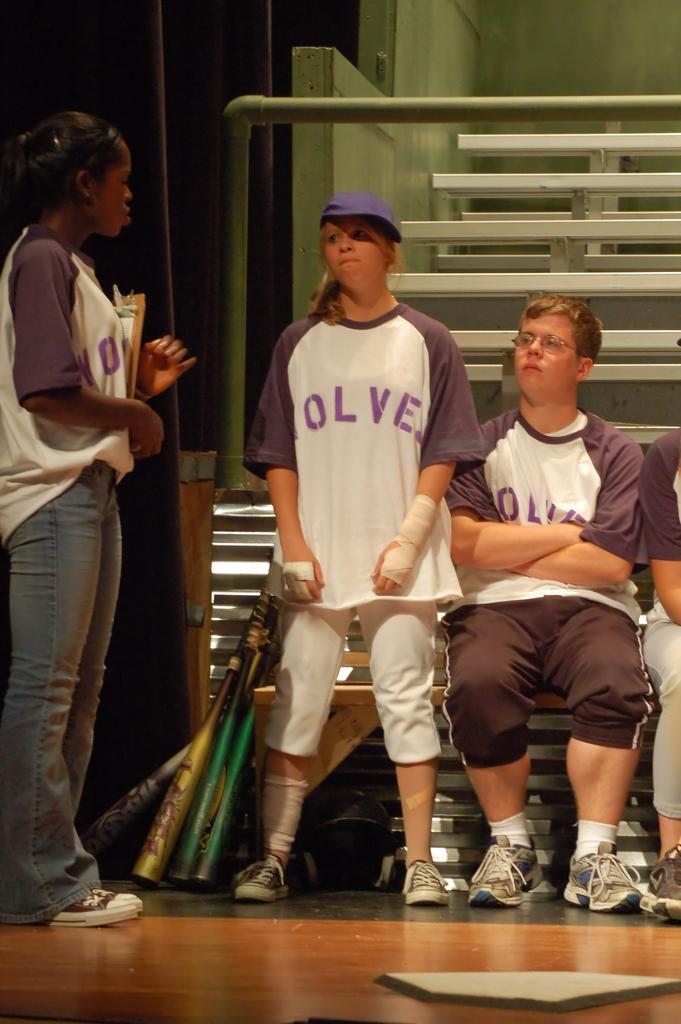<image>
Render a clear and concise summary of the photo. Girl wearing a shirt which says Wolves standing next to another girl. 